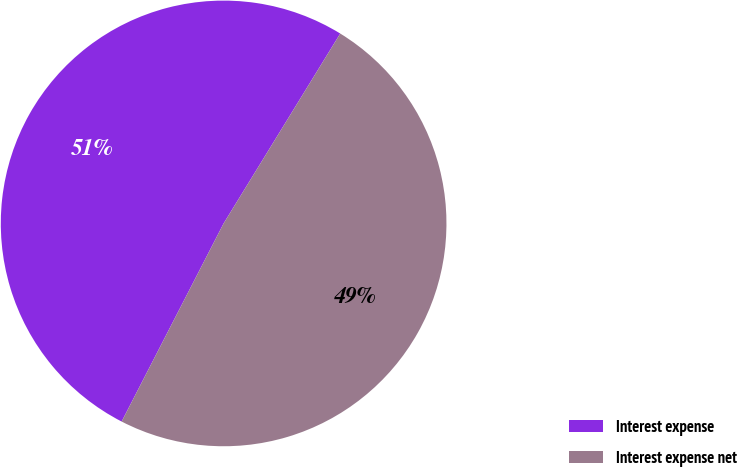Convert chart. <chart><loc_0><loc_0><loc_500><loc_500><pie_chart><fcel>Interest expense<fcel>Interest expense net<nl><fcel>51.2%<fcel>48.8%<nl></chart> 